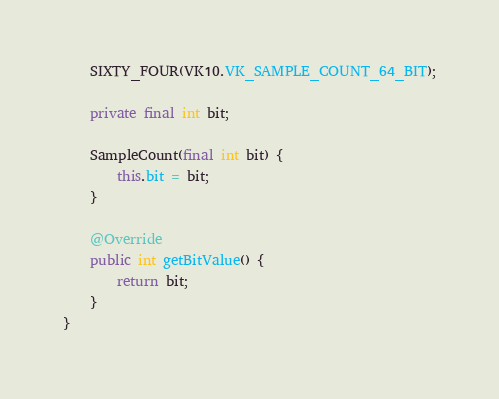Convert code to text. <code><loc_0><loc_0><loc_500><loc_500><_Java_>    SIXTY_FOUR(VK10.VK_SAMPLE_COUNT_64_BIT);
    
    private final int bit;
    
    SampleCount(final int bit) {
        this.bit = bit;
    }

    @Override
    public int getBitValue() {
        return bit;
    }
}
</code> 